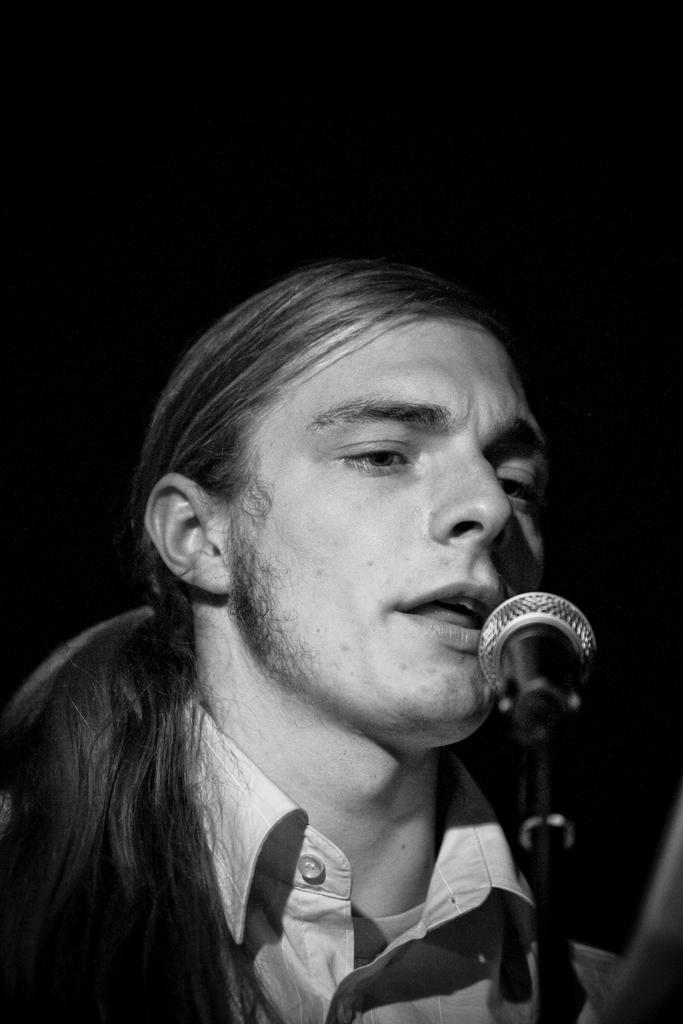Could you give a brief overview of what you see in this image? In this image I can see a person singing in front of the microphone and the image is in black and white. 